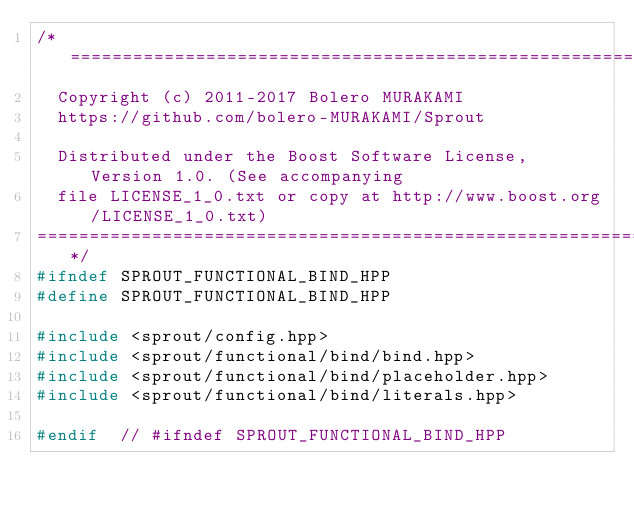<code> <loc_0><loc_0><loc_500><loc_500><_C++_>/*=============================================================================
  Copyright (c) 2011-2017 Bolero MURAKAMI
  https://github.com/bolero-MURAKAMI/Sprout

  Distributed under the Boost Software License, Version 1.0. (See accompanying
  file LICENSE_1_0.txt or copy at http://www.boost.org/LICENSE_1_0.txt)
=============================================================================*/
#ifndef SPROUT_FUNCTIONAL_BIND_HPP
#define SPROUT_FUNCTIONAL_BIND_HPP

#include <sprout/config.hpp>
#include <sprout/functional/bind/bind.hpp>
#include <sprout/functional/bind/placeholder.hpp>
#include <sprout/functional/bind/literals.hpp>

#endif	// #ifndef SPROUT_FUNCTIONAL_BIND_HPP
</code> 